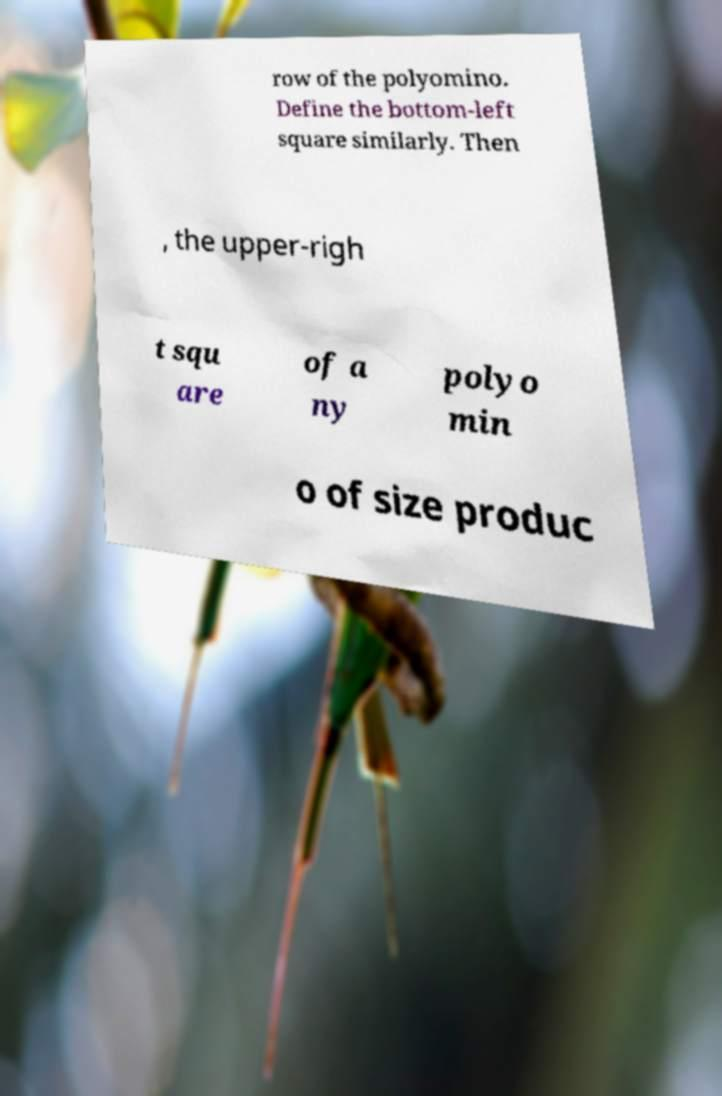Can you accurately transcribe the text from the provided image for me? row of the polyomino. Define the bottom-left square similarly. Then , the upper-righ t squ are of a ny polyo min o of size produc 